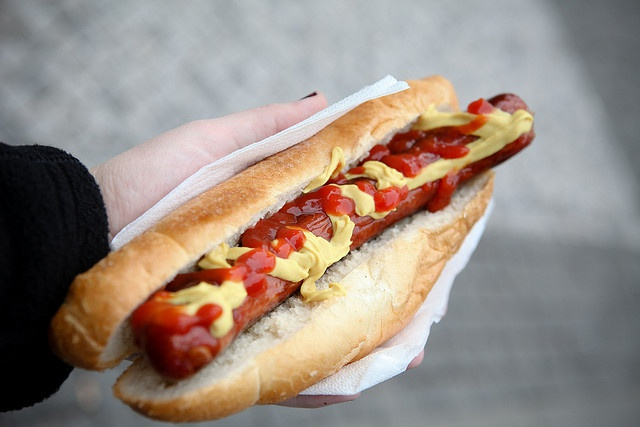Describe the objects in this image and their specific colors. I can see hot dog in gray, tan, maroon, and beige tones and people in gray, black, lightgray, and darkgray tones in this image. 